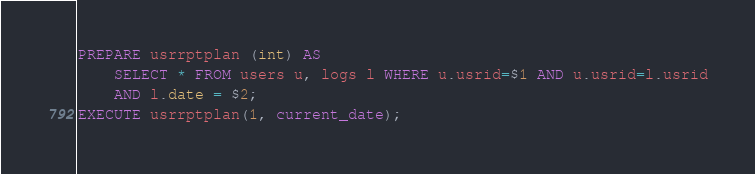Convert code to text. <code><loc_0><loc_0><loc_500><loc_500><_SQL_>PREPARE usrrptplan (int) AS
    SELECT * FROM users u, logs l WHERE u.usrid=$1 AND u.usrid=l.usrid
    AND l.date = $2;
EXECUTE usrrptplan(1, current_date);
</code> 